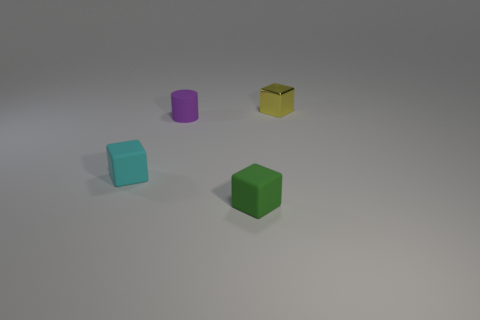Add 3 big gray metallic balls. How many objects exist? 7 Subtract all cubes. How many objects are left? 1 Subtract all small matte objects. Subtract all green objects. How many objects are left? 0 Add 4 cyan matte cubes. How many cyan matte cubes are left? 5 Add 3 yellow rubber spheres. How many yellow rubber spheres exist? 3 Subtract 0 cyan balls. How many objects are left? 4 